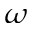<formula> <loc_0><loc_0><loc_500><loc_500>{ \omega }</formula> 